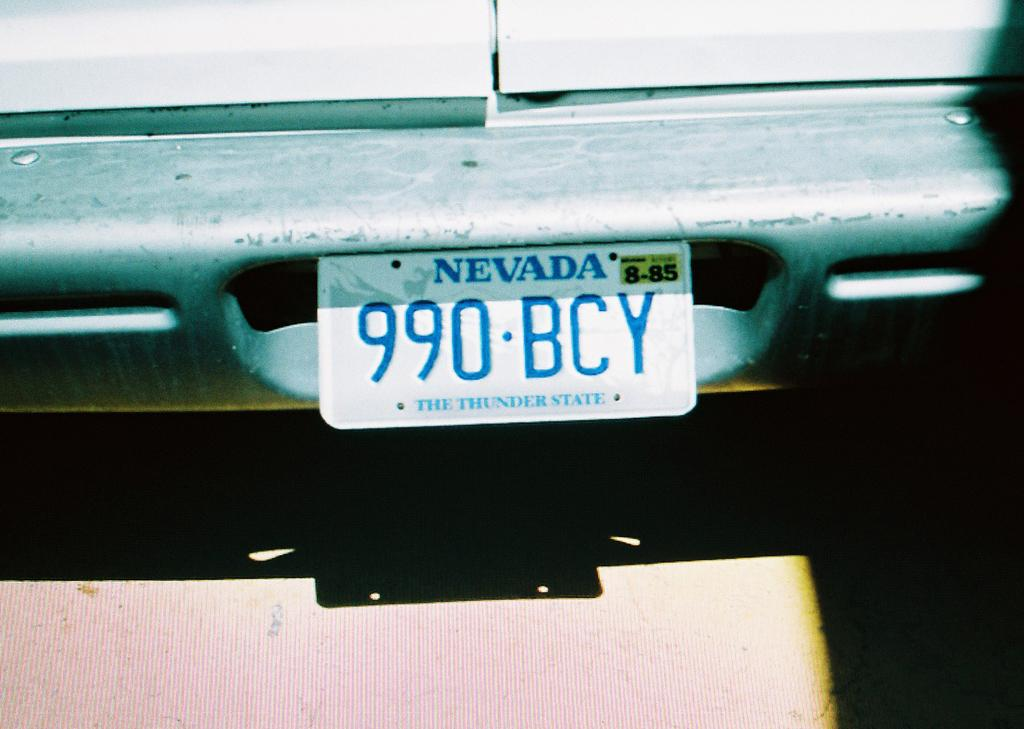<image>
Present a compact description of the photo's key features. a Nevada license plate that is on a car 